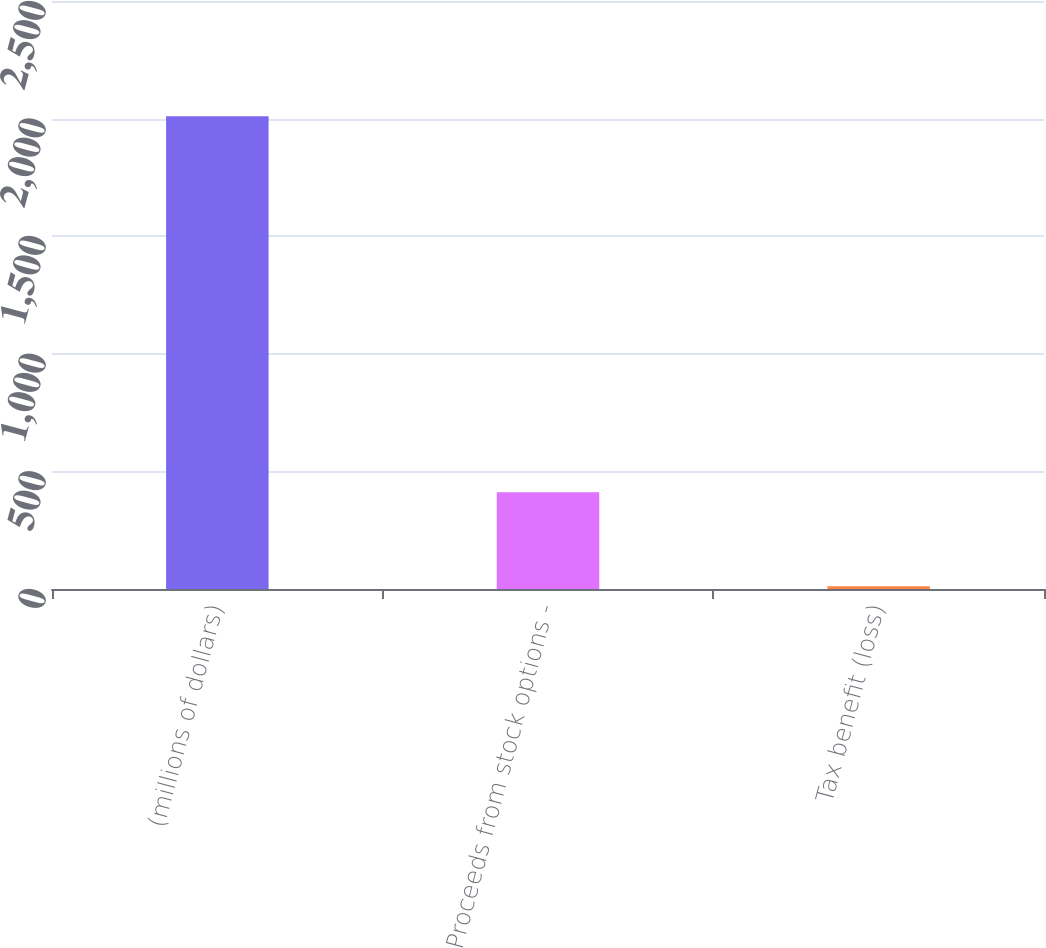Convert chart. <chart><loc_0><loc_0><loc_500><loc_500><bar_chart><fcel>(millions of dollars)<fcel>Proceeds from stock options -<fcel>Tax benefit (loss)<nl><fcel>2010<fcel>411.36<fcel>11.7<nl></chart> 